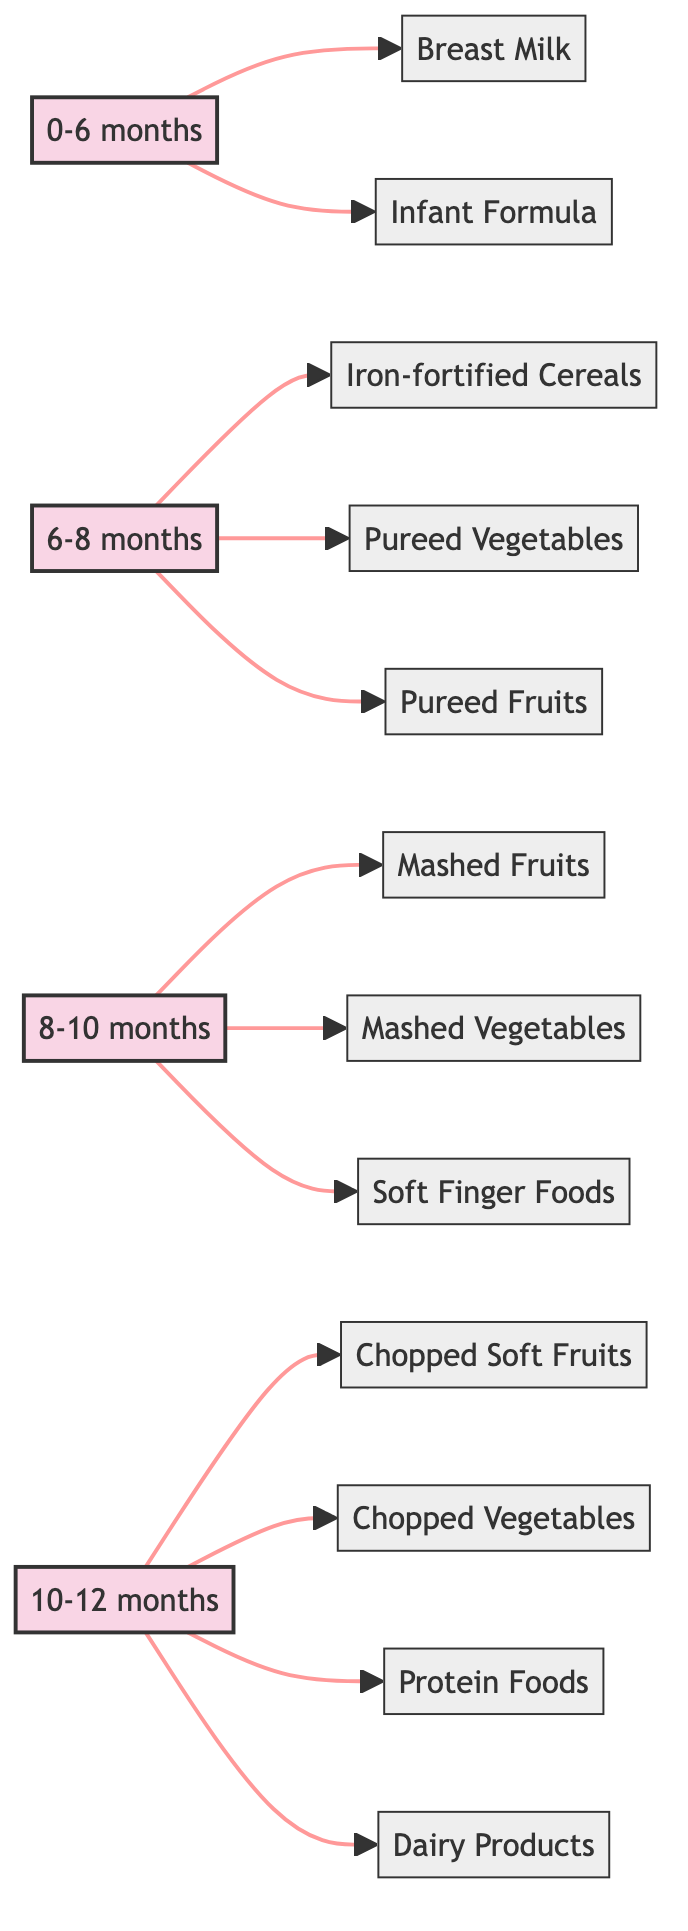What age group includes Breast Milk? Breast Milk is listed under the age group "0-6 months". This can be seen directly from the first section of the flowchart that states the age range.
Answer: 0-6 months How many foods are listed for the age group 8-10 months? The age group "8-10 months" includes three foods: Mashed Fruits, Mashed Vegetables, and Soft Finger Foods. Counting these foods gives us the number.
Answer: 3 What is the relationship between Iron-fortified Cereals and the age group 6-8 months? Iron-fortified Cereals is a food item directly connected to the age group "6-8 months" in the flowchart. This indicates that it is suitable for that age range.
Answer: food item Which food comes first in the 10-12 months age category? The first food listed under the age group "10-12 months" is Chopped Soft Fruits. The order of the food items is shown sequentially in the flowchart.
Answer: Chopped Soft Fruits Are Pureed Vegetables and Pureed Fruits both included in the same age category? Yes, both Pureed Vegetables and Pureed Fruits are foods listed under the age group "6-8 months". They are connected by the same section of the flowchart.
Answer: Yes What type of foods are introduced at 10-12 months? In the 10-12 months age category, the foods include Chopped Soft Fruits, Chopped Vegetables, Protein Foods, and Dairy Products. The flowchart shows a variety of food types suitable for this age.
Answer: Chopped Soft Fruits, Chopped Vegetables, Protein Foods, Dairy Products Which age group has the highest number of food items listed? The age group "10-12 months" has four food items listed, which is more than any other age group in the flowchart. This is determined by counting the entries in each age group.
Answer: 10-12 months What ingredient is suggested for infants ages 0-6 months? Breast Milk is suggested as the primary ingredient for infants in the age group 0-6 months. This is explicitly stated in the flowchart under that age category.
Answer: Breast Milk How are the age groups visually separated in the diagram? The age groups are visually separated by distinct sections with titles, where each age range has a colored box indicating its category, leading to various food items. This structural setup aids in easy navigation of the flowchart.
Answer: Colored boxes 